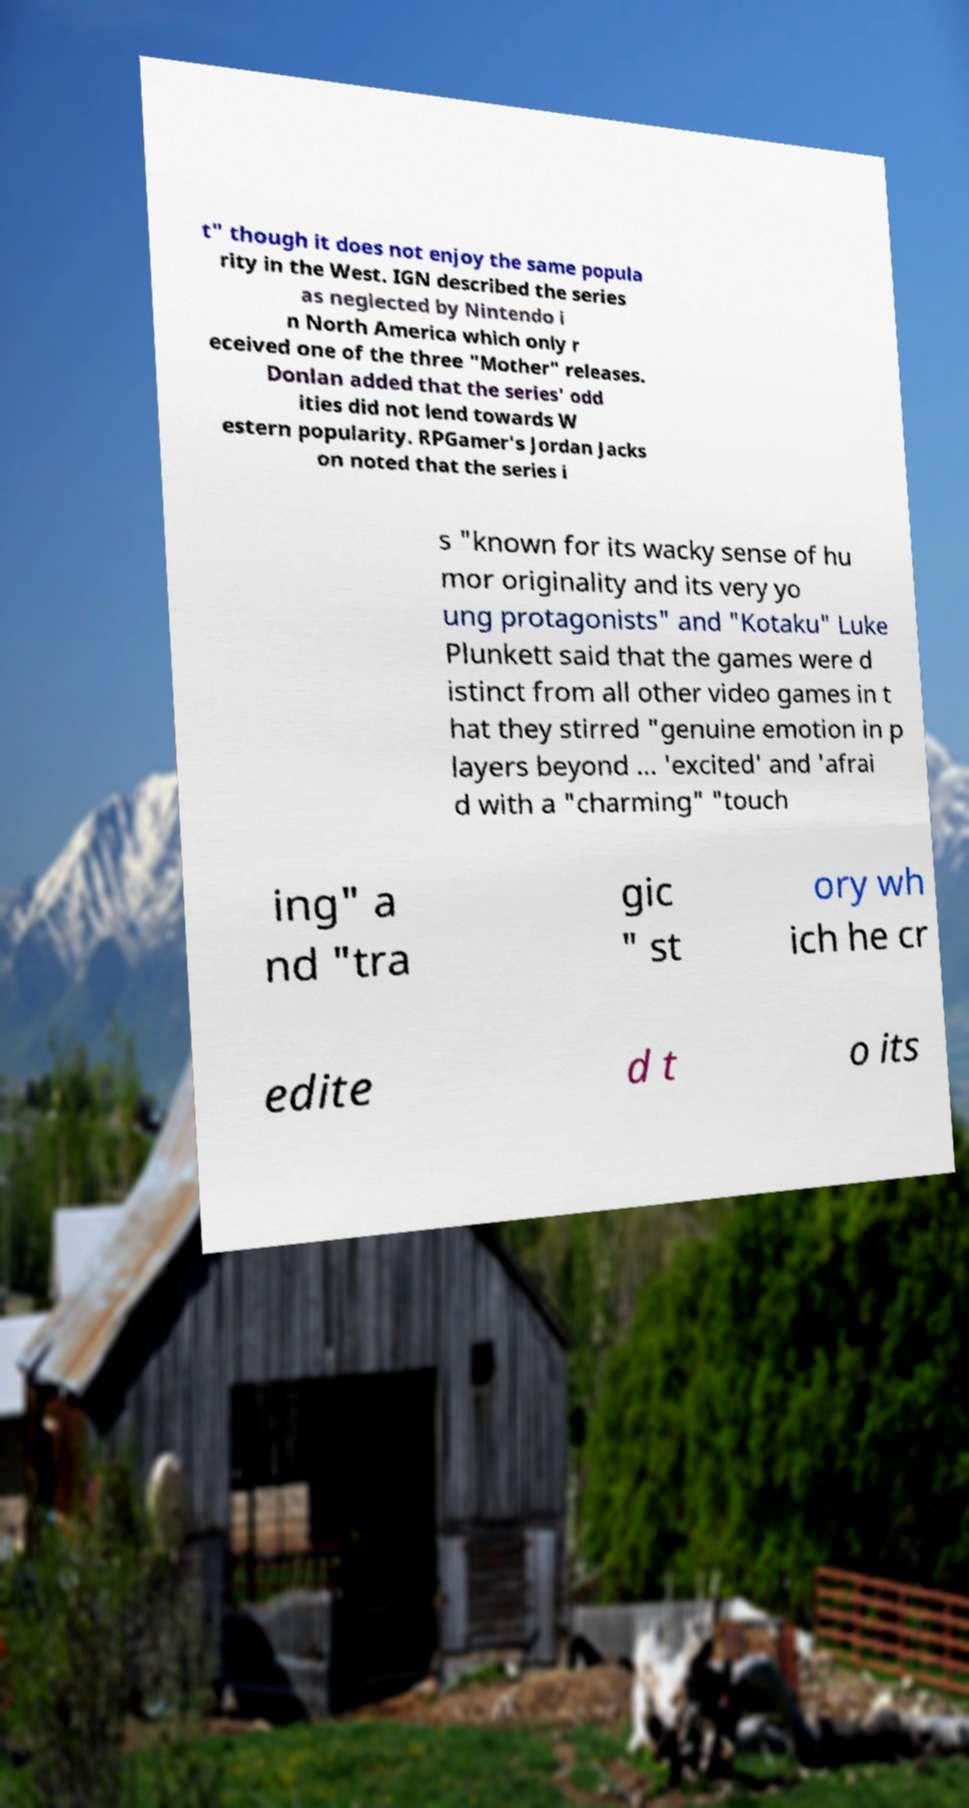Please read and relay the text visible in this image. What does it say? t" though it does not enjoy the same popula rity in the West. IGN described the series as neglected by Nintendo i n North America which only r eceived one of the three "Mother" releases. Donlan added that the series' odd ities did not lend towards W estern popularity. RPGamer's Jordan Jacks on noted that the series i s "known for its wacky sense of hu mor originality and its very yo ung protagonists" and "Kotaku" Luke Plunkett said that the games were d istinct from all other video games in t hat they stirred "genuine emotion in p layers beyond ... 'excited' and 'afrai d with a "charming" "touch ing" a nd "tra gic " st ory wh ich he cr edite d t o its 